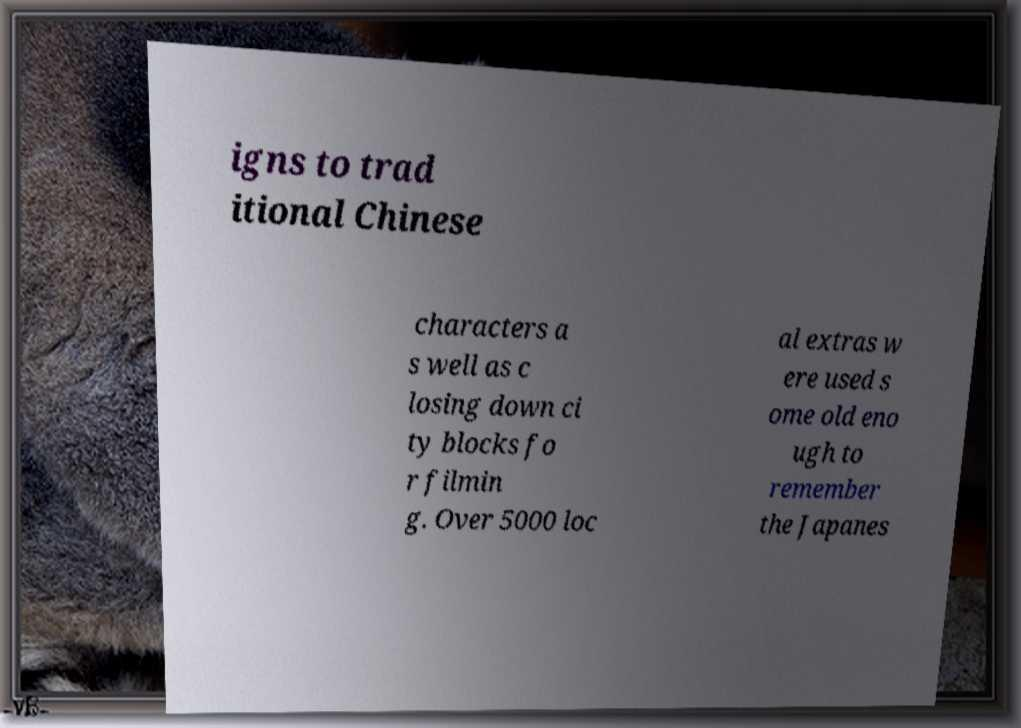Please identify and transcribe the text found in this image. igns to trad itional Chinese characters a s well as c losing down ci ty blocks fo r filmin g. Over 5000 loc al extras w ere used s ome old eno ugh to remember the Japanes 